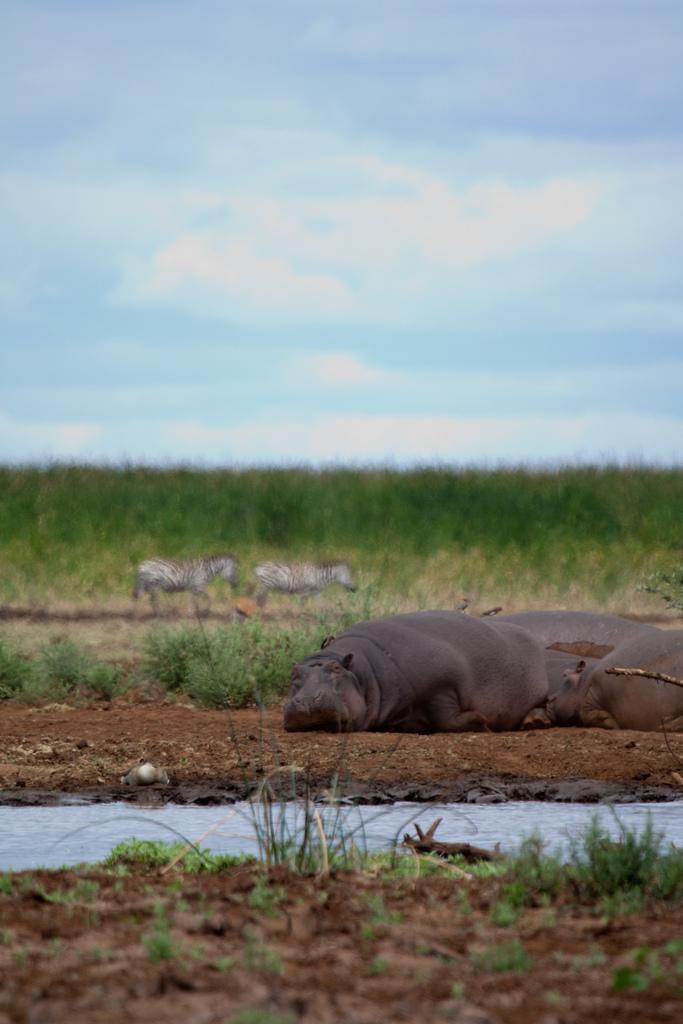Describe this image in one or two sentences. In front of the image there is water flowing, behind the water, there are three animals slept in the mud, behind that there are two giraffes walking, behind the giraffes there is grass. 